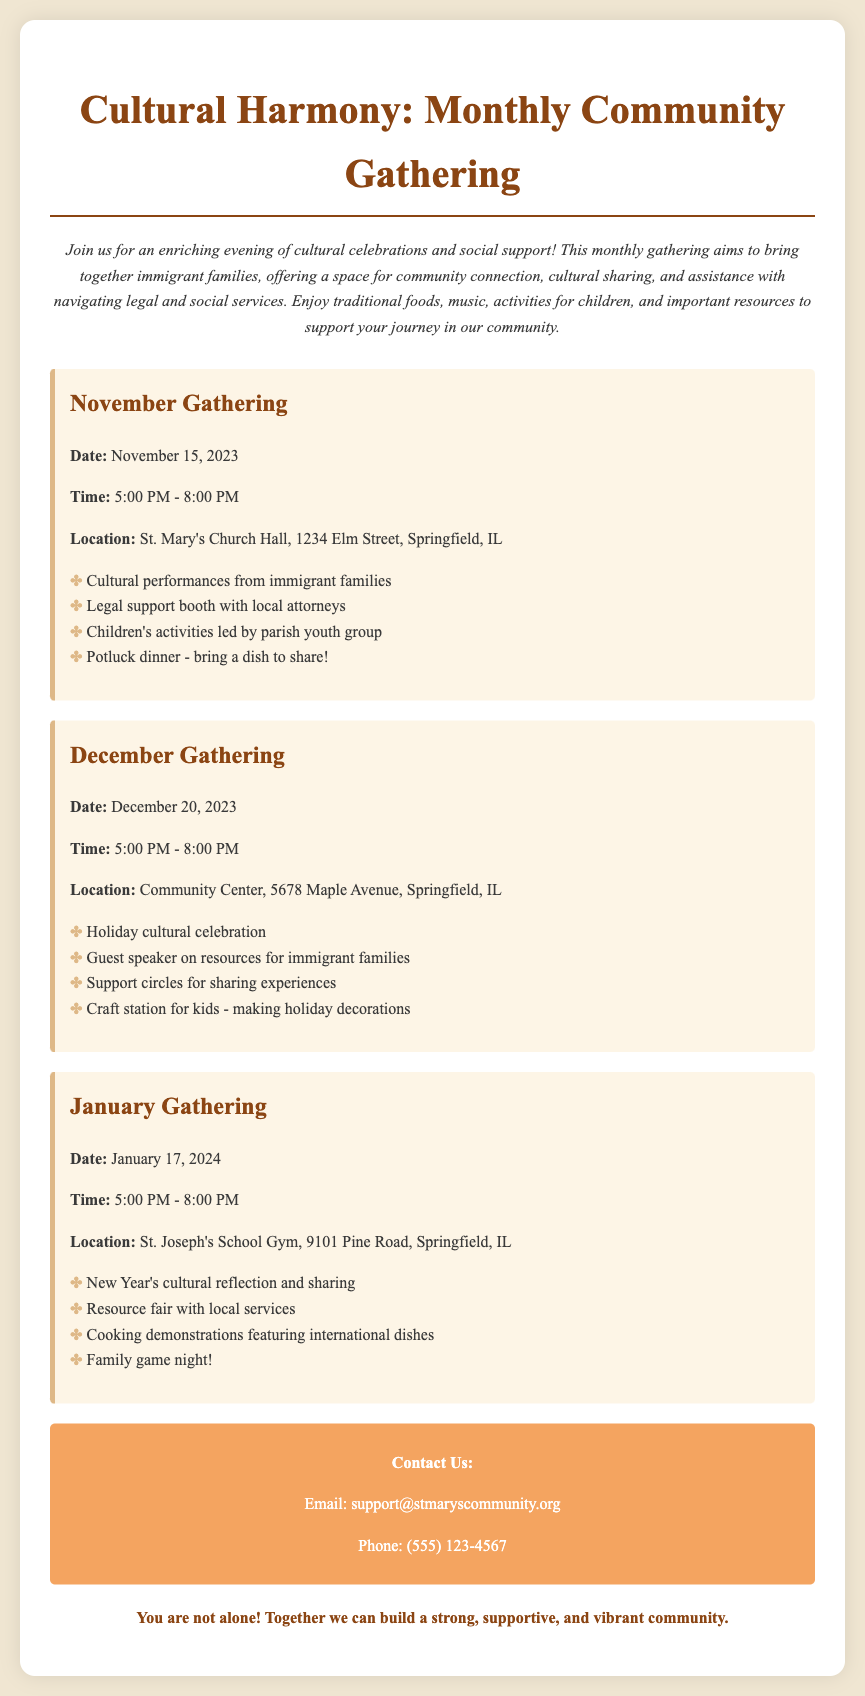What is the title of the event? The title of the event is presented at the top of the document, indicating its focus on cultural gatherings.
Answer: Cultural Harmony: Monthly Community Gathering When is the November gathering scheduled? The date for the November gathering is specifically mentioned in its section within the document.
Answer: November 15, 2023 What time does the December gathering start? The starting time for the December gathering is clearly stated in the relevant section of the document.
Answer: 5:00 PM Where will the January gathering take place? The location for the January gathering is explicitly noted in its section.
Answer: St. Joseph's School Gym, 9101 Pine Road, Springfield, IL What type of event is included in the January gathering? The January gathering includes cultural reflection and is indicated as a focus of this specific event.
Answer: New Year's cultural reflection and sharing How long does each gathering last? The time span for each gathering is consistently mentioned, revealing the overall duration.
Answer: 3 hours What community resources are offered at the November event? The November gathering's listings include a specific resource focus that supports the attendees.
Answer: Legal support booth with local attorneys Who can you contact for more information? The contact information section provides specific ways to reach out for further inquiry.
Answer: support@stmaryscommunity.org What type of activities are offered for children at the December gathering? The activities specifically designed for children at the December event are outlined within its details.
Answer: Craft station for kids - making holiday decorations 